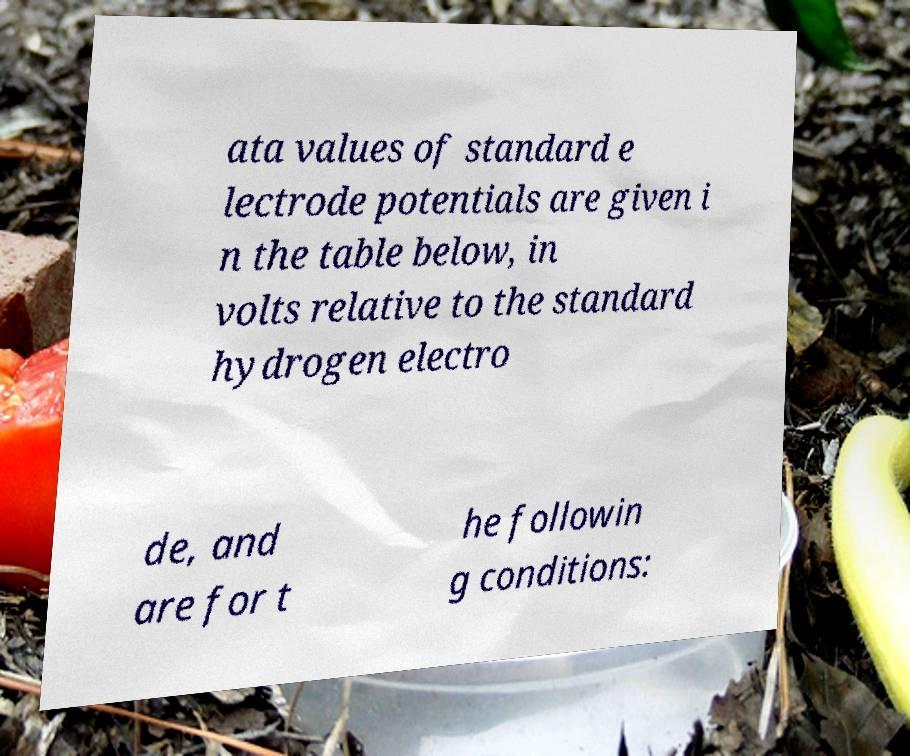For documentation purposes, I need the text within this image transcribed. Could you provide that? ata values of standard e lectrode potentials are given i n the table below, in volts relative to the standard hydrogen electro de, and are for t he followin g conditions: 